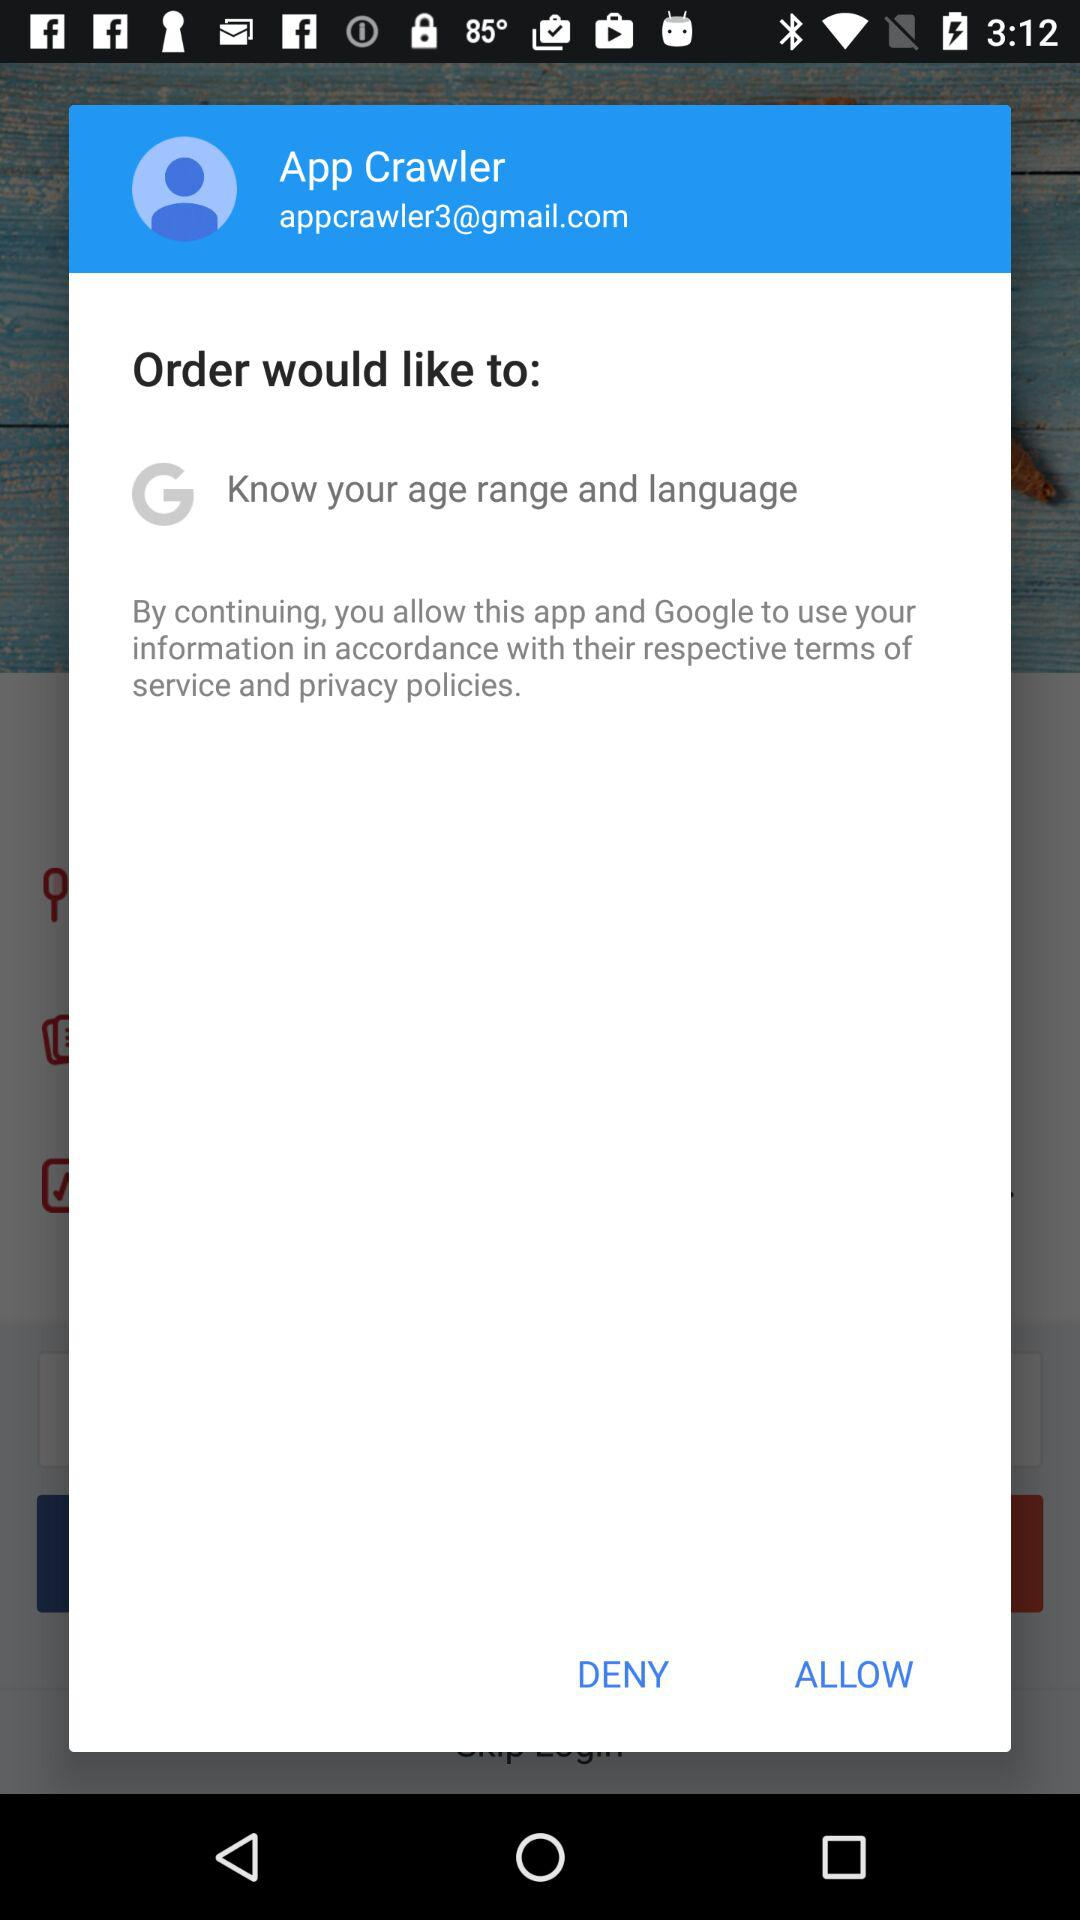What is the email address? The email address is appcrawler3@gmail.com. 